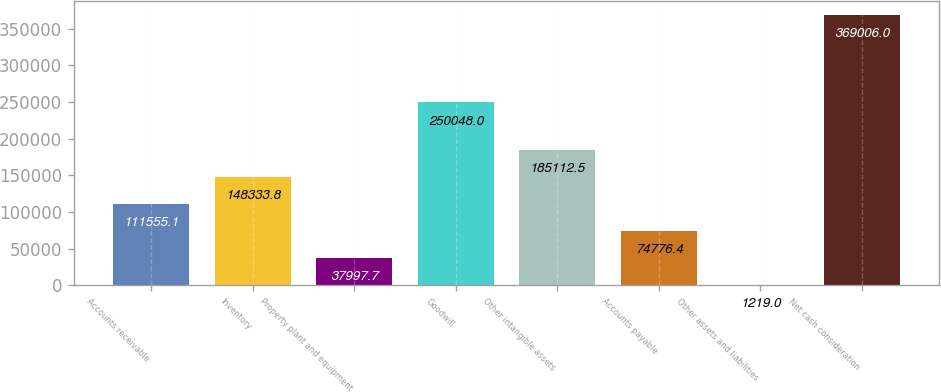<chart> <loc_0><loc_0><loc_500><loc_500><bar_chart><fcel>Accounts receivable<fcel>Inventory<fcel>Property plant and equipment<fcel>Goodwill<fcel>Other intangible assets<fcel>Accounts payable<fcel>Other assets and liabilities<fcel>Net cash consideration<nl><fcel>111555<fcel>148334<fcel>37997.7<fcel>250048<fcel>185112<fcel>74776.4<fcel>1219<fcel>369006<nl></chart> 